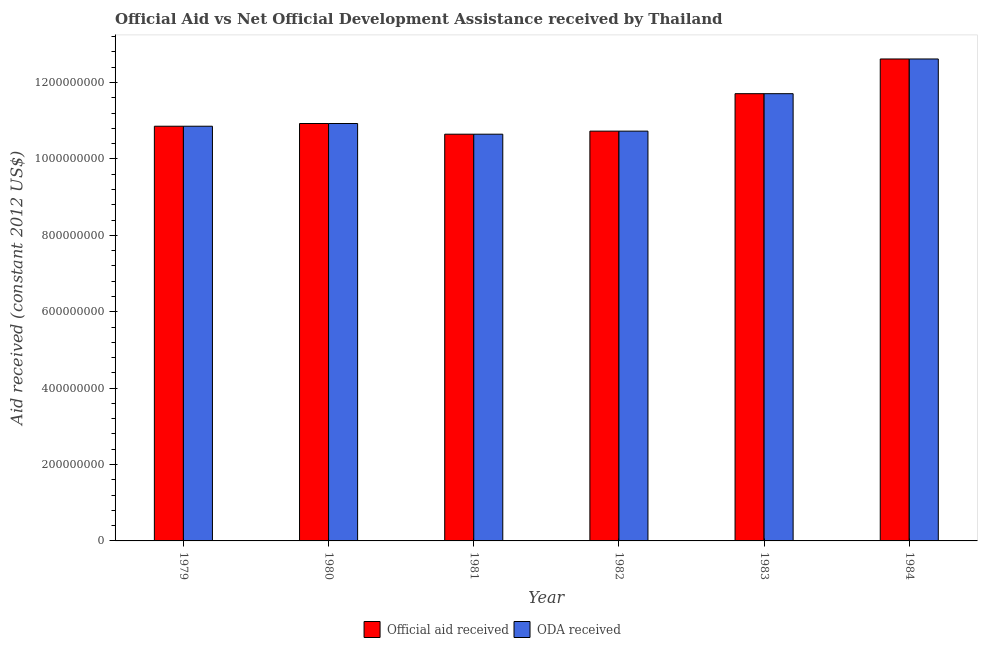How many different coloured bars are there?
Your response must be concise. 2. How many groups of bars are there?
Your answer should be very brief. 6. Are the number of bars per tick equal to the number of legend labels?
Give a very brief answer. Yes. How many bars are there on the 2nd tick from the right?
Offer a very short reply. 2. In how many cases, is the number of bars for a given year not equal to the number of legend labels?
Your answer should be very brief. 0. What is the official aid received in 1982?
Offer a terse response. 1.07e+09. Across all years, what is the maximum official aid received?
Keep it short and to the point. 1.26e+09. Across all years, what is the minimum official aid received?
Your answer should be very brief. 1.06e+09. In which year was the oda received maximum?
Ensure brevity in your answer.  1984. What is the total official aid received in the graph?
Give a very brief answer. 6.75e+09. What is the difference between the oda received in 1979 and that in 1981?
Your answer should be compact. 2.09e+07. What is the difference between the official aid received in 1980 and the oda received in 1983?
Your response must be concise. -7.81e+07. What is the average oda received per year?
Provide a short and direct response. 1.12e+09. In the year 1981, what is the difference between the official aid received and oda received?
Provide a succinct answer. 0. What is the ratio of the official aid received in 1979 to that in 1980?
Your response must be concise. 0.99. What is the difference between the highest and the second highest official aid received?
Make the answer very short. 9.09e+07. What is the difference between the highest and the lowest oda received?
Offer a very short reply. 1.97e+08. Is the sum of the official aid received in 1982 and 1984 greater than the maximum oda received across all years?
Your answer should be very brief. Yes. What does the 1st bar from the left in 1982 represents?
Your answer should be compact. Official aid received. What does the 2nd bar from the right in 1984 represents?
Your answer should be compact. Official aid received. Are all the bars in the graph horizontal?
Your response must be concise. No. Does the graph contain any zero values?
Your answer should be very brief. No. How many legend labels are there?
Offer a terse response. 2. What is the title of the graph?
Give a very brief answer. Official Aid vs Net Official Development Assistance received by Thailand . Does "ODA received" appear as one of the legend labels in the graph?
Offer a very short reply. Yes. What is the label or title of the Y-axis?
Your response must be concise. Aid received (constant 2012 US$). What is the Aid received (constant 2012 US$) in Official aid received in 1979?
Ensure brevity in your answer.  1.09e+09. What is the Aid received (constant 2012 US$) of ODA received in 1979?
Offer a very short reply. 1.09e+09. What is the Aid received (constant 2012 US$) in Official aid received in 1980?
Offer a very short reply. 1.09e+09. What is the Aid received (constant 2012 US$) in ODA received in 1980?
Your answer should be compact. 1.09e+09. What is the Aid received (constant 2012 US$) of Official aid received in 1981?
Ensure brevity in your answer.  1.06e+09. What is the Aid received (constant 2012 US$) of ODA received in 1981?
Ensure brevity in your answer.  1.06e+09. What is the Aid received (constant 2012 US$) of Official aid received in 1982?
Provide a short and direct response. 1.07e+09. What is the Aid received (constant 2012 US$) in ODA received in 1982?
Provide a succinct answer. 1.07e+09. What is the Aid received (constant 2012 US$) of Official aid received in 1983?
Keep it short and to the point. 1.17e+09. What is the Aid received (constant 2012 US$) in ODA received in 1983?
Make the answer very short. 1.17e+09. What is the Aid received (constant 2012 US$) in Official aid received in 1984?
Ensure brevity in your answer.  1.26e+09. What is the Aid received (constant 2012 US$) in ODA received in 1984?
Provide a succinct answer. 1.26e+09. Across all years, what is the maximum Aid received (constant 2012 US$) of Official aid received?
Give a very brief answer. 1.26e+09. Across all years, what is the maximum Aid received (constant 2012 US$) in ODA received?
Your answer should be compact. 1.26e+09. Across all years, what is the minimum Aid received (constant 2012 US$) of Official aid received?
Ensure brevity in your answer.  1.06e+09. Across all years, what is the minimum Aid received (constant 2012 US$) in ODA received?
Offer a very short reply. 1.06e+09. What is the total Aid received (constant 2012 US$) in Official aid received in the graph?
Provide a short and direct response. 6.75e+09. What is the total Aid received (constant 2012 US$) of ODA received in the graph?
Your response must be concise. 6.75e+09. What is the difference between the Aid received (constant 2012 US$) of Official aid received in 1979 and that in 1980?
Ensure brevity in your answer.  -7.12e+06. What is the difference between the Aid received (constant 2012 US$) in ODA received in 1979 and that in 1980?
Keep it short and to the point. -7.12e+06. What is the difference between the Aid received (constant 2012 US$) in Official aid received in 1979 and that in 1981?
Your answer should be very brief. 2.09e+07. What is the difference between the Aid received (constant 2012 US$) in ODA received in 1979 and that in 1981?
Offer a very short reply. 2.09e+07. What is the difference between the Aid received (constant 2012 US$) of Official aid received in 1979 and that in 1982?
Keep it short and to the point. 1.29e+07. What is the difference between the Aid received (constant 2012 US$) in ODA received in 1979 and that in 1982?
Offer a very short reply. 1.29e+07. What is the difference between the Aid received (constant 2012 US$) of Official aid received in 1979 and that in 1983?
Ensure brevity in your answer.  -8.52e+07. What is the difference between the Aid received (constant 2012 US$) of ODA received in 1979 and that in 1983?
Your answer should be compact. -8.52e+07. What is the difference between the Aid received (constant 2012 US$) of Official aid received in 1979 and that in 1984?
Make the answer very short. -1.76e+08. What is the difference between the Aid received (constant 2012 US$) of ODA received in 1979 and that in 1984?
Provide a short and direct response. -1.76e+08. What is the difference between the Aid received (constant 2012 US$) in Official aid received in 1980 and that in 1981?
Your answer should be very brief. 2.80e+07. What is the difference between the Aid received (constant 2012 US$) in ODA received in 1980 and that in 1981?
Your answer should be compact. 2.80e+07. What is the difference between the Aid received (constant 2012 US$) in Official aid received in 1980 and that in 1982?
Give a very brief answer. 2.00e+07. What is the difference between the Aid received (constant 2012 US$) of ODA received in 1980 and that in 1982?
Provide a succinct answer. 2.00e+07. What is the difference between the Aid received (constant 2012 US$) in Official aid received in 1980 and that in 1983?
Offer a very short reply. -7.81e+07. What is the difference between the Aid received (constant 2012 US$) of ODA received in 1980 and that in 1983?
Your answer should be compact. -7.81e+07. What is the difference between the Aid received (constant 2012 US$) in Official aid received in 1980 and that in 1984?
Provide a succinct answer. -1.69e+08. What is the difference between the Aid received (constant 2012 US$) of ODA received in 1980 and that in 1984?
Make the answer very short. -1.69e+08. What is the difference between the Aid received (constant 2012 US$) in Official aid received in 1981 and that in 1982?
Make the answer very short. -8.00e+06. What is the difference between the Aid received (constant 2012 US$) in ODA received in 1981 and that in 1982?
Provide a short and direct response. -8.00e+06. What is the difference between the Aid received (constant 2012 US$) in Official aid received in 1981 and that in 1983?
Your response must be concise. -1.06e+08. What is the difference between the Aid received (constant 2012 US$) in ODA received in 1981 and that in 1983?
Your answer should be compact. -1.06e+08. What is the difference between the Aid received (constant 2012 US$) in Official aid received in 1981 and that in 1984?
Provide a succinct answer. -1.97e+08. What is the difference between the Aid received (constant 2012 US$) of ODA received in 1981 and that in 1984?
Your response must be concise. -1.97e+08. What is the difference between the Aid received (constant 2012 US$) of Official aid received in 1982 and that in 1983?
Your answer should be compact. -9.80e+07. What is the difference between the Aid received (constant 2012 US$) of ODA received in 1982 and that in 1983?
Your answer should be very brief. -9.80e+07. What is the difference between the Aid received (constant 2012 US$) in Official aid received in 1982 and that in 1984?
Your answer should be compact. -1.89e+08. What is the difference between the Aid received (constant 2012 US$) in ODA received in 1982 and that in 1984?
Offer a terse response. -1.89e+08. What is the difference between the Aid received (constant 2012 US$) of Official aid received in 1983 and that in 1984?
Provide a short and direct response. -9.09e+07. What is the difference between the Aid received (constant 2012 US$) in ODA received in 1983 and that in 1984?
Ensure brevity in your answer.  -9.09e+07. What is the difference between the Aid received (constant 2012 US$) in Official aid received in 1979 and the Aid received (constant 2012 US$) in ODA received in 1980?
Your answer should be very brief. -7.12e+06. What is the difference between the Aid received (constant 2012 US$) of Official aid received in 1979 and the Aid received (constant 2012 US$) of ODA received in 1981?
Your answer should be very brief. 2.09e+07. What is the difference between the Aid received (constant 2012 US$) in Official aid received in 1979 and the Aid received (constant 2012 US$) in ODA received in 1982?
Ensure brevity in your answer.  1.29e+07. What is the difference between the Aid received (constant 2012 US$) in Official aid received in 1979 and the Aid received (constant 2012 US$) in ODA received in 1983?
Your answer should be very brief. -8.52e+07. What is the difference between the Aid received (constant 2012 US$) in Official aid received in 1979 and the Aid received (constant 2012 US$) in ODA received in 1984?
Your answer should be very brief. -1.76e+08. What is the difference between the Aid received (constant 2012 US$) of Official aid received in 1980 and the Aid received (constant 2012 US$) of ODA received in 1981?
Your response must be concise. 2.80e+07. What is the difference between the Aid received (constant 2012 US$) of Official aid received in 1980 and the Aid received (constant 2012 US$) of ODA received in 1982?
Provide a short and direct response. 2.00e+07. What is the difference between the Aid received (constant 2012 US$) in Official aid received in 1980 and the Aid received (constant 2012 US$) in ODA received in 1983?
Ensure brevity in your answer.  -7.81e+07. What is the difference between the Aid received (constant 2012 US$) in Official aid received in 1980 and the Aid received (constant 2012 US$) in ODA received in 1984?
Ensure brevity in your answer.  -1.69e+08. What is the difference between the Aid received (constant 2012 US$) in Official aid received in 1981 and the Aid received (constant 2012 US$) in ODA received in 1982?
Your response must be concise. -8.00e+06. What is the difference between the Aid received (constant 2012 US$) of Official aid received in 1981 and the Aid received (constant 2012 US$) of ODA received in 1983?
Give a very brief answer. -1.06e+08. What is the difference between the Aid received (constant 2012 US$) in Official aid received in 1981 and the Aid received (constant 2012 US$) in ODA received in 1984?
Offer a terse response. -1.97e+08. What is the difference between the Aid received (constant 2012 US$) in Official aid received in 1982 and the Aid received (constant 2012 US$) in ODA received in 1983?
Give a very brief answer. -9.80e+07. What is the difference between the Aid received (constant 2012 US$) of Official aid received in 1982 and the Aid received (constant 2012 US$) of ODA received in 1984?
Your answer should be very brief. -1.89e+08. What is the difference between the Aid received (constant 2012 US$) of Official aid received in 1983 and the Aid received (constant 2012 US$) of ODA received in 1984?
Provide a succinct answer. -9.09e+07. What is the average Aid received (constant 2012 US$) of Official aid received per year?
Make the answer very short. 1.12e+09. What is the average Aid received (constant 2012 US$) in ODA received per year?
Your answer should be compact. 1.12e+09. In the year 1979, what is the difference between the Aid received (constant 2012 US$) in Official aid received and Aid received (constant 2012 US$) in ODA received?
Your answer should be compact. 0. In the year 1981, what is the difference between the Aid received (constant 2012 US$) in Official aid received and Aid received (constant 2012 US$) in ODA received?
Provide a short and direct response. 0. In the year 1983, what is the difference between the Aid received (constant 2012 US$) in Official aid received and Aid received (constant 2012 US$) in ODA received?
Provide a succinct answer. 0. In the year 1984, what is the difference between the Aid received (constant 2012 US$) in Official aid received and Aid received (constant 2012 US$) in ODA received?
Your response must be concise. 0. What is the ratio of the Aid received (constant 2012 US$) of Official aid received in 1979 to that in 1980?
Offer a terse response. 0.99. What is the ratio of the Aid received (constant 2012 US$) of Official aid received in 1979 to that in 1981?
Your answer should be very brief. 1.02. What is the ratio of the Aid received (constant 2012 US$) of ODA received in 1979 to that in 1981?
Ensure brevity in your answer.  1.02. What is the ratio of the Aid received (constant 2012 US$) in ODA received in 1979 to that in 1982?
Provide a short and direct response. 1.01. What is the ratio of the Aid received (constant 2012 US$) in Official aid received in 1979 to that in 1983?
Ensure brevity in your answer.  0.93. What is the ratio of the Aid received (constant 2012 US$) in ODA received in 1979 to that in 1983?
Offer a terse response. 0.93. What is the ratio of the Aid received (constant 2012 US$) in Official aid received in 1979 to that in 1984?
Keep it short and to the point. 0.86. What is the ratio of the Aid received (constant 2012 US$) of ODA received in 1979 to that in 1984?
Your answer should be very brief. 0.86. What is the ratio of the Aid received (constant 2012 US$) in Official aid received in 1980 to that in 1981?
Ensure brevity in your answer.  1.03. What is the ratio of the Aid received (constant 2012 US$) of ODA received in 1980 to that in 1981?
Offer a terse response. 1.03. What is the ratio of the Aid received (constant 2012 US$) of Official aid received in 1980 to that in 1982?
Provide a short and direct response. 1.02. What is the ratio of the Aid received (constant 2012 US$) of ODA received in 1980 to that in 1982?
Your response must be concise. 1.02. What is the ratio of the Aid received (constant 2012 US$) in Official aid received in 1980 to that in 1983?
Offer a terse response. 0.93. What is the ratio of the Aid received (constant 2012 US$) in ODA received in 1980 to that in 1983?
Provide a succinct answer. 0.93. What is the ratio of the Aid received (constant 2012 US$) of Official aid received in 1980 to that in 1984?
Make the answer very short. 0.87. What is the ratio of the Aid received (constant 2012 US$) of ODA received in 1980 to that in 1984?
Offer a terse response. 0.87. What is the ratio of the Aid received (constant 2012 US$) of Official aid received in 1981 to that in 1983?
Offer a very short reply. 0.91. What is the ratio of the Aid received (constant 2012 US$) in ODA received in 1981 to that in 1983?
Provide a succinct answer. 0.91. What is the ratio of the Aid received (constant 2012 US$) in Official aid received in 1981 to that in 1984?
Ensure brevity in your answer.  0.84. What is the ratio of the Aid received (constant 2012 US$) of ODA received in 1981 to that in 1984?
Provide a succinct answer. 0.84. What is the ratio of the Aid received (constant 2012 US$) in Official aid received in 1982 to that in 1983?
Give a very brief answer. 0.92. What is the ratio of the Aid received (constant 2012 US$) in ODA received in 1982 to that in 1983?
Ensure brevity in your answer.  0.92. What is the ratio of the Aid received (constant 2012 US$) of Official aid received in 1982 to that in 1984?
Provide a succinct answer. 0.85. What is the ratio of the Aid received (constant 2012 US$) of ODA received in 1982 to that in 1984?
Provide a succinct answer. 0.85. What is the ratio of the Aid received (constant 2012 US$) in Official aid received in 1983 to that in 1984?
Offer a very short reply. 0.93. What is the ratio of the Aid received (constant 2012 US$) of ODA received in 1983 to that in 1984?
Provide a succinct answer. 0.93. What is the difference between the highest and the second highest Aid received (constant 2012 US$) of Official aid received?
Provide a succinct answer. 9.09e+07. What is the difference between the highest and the second highest Aid received (constant 2012 US$) of ODA received?
Offer a very short reply. 9.09e+07. What is the difference between the highest and the lowest Aid received (constant 2012 US$) in Official aid received?
Make the answer very short. 1.97e+08. What is the difference between the highest and the lowest Aid received (constant 2012 US$) of ODA received?
Offer a very short reply. 1.97e+08. 